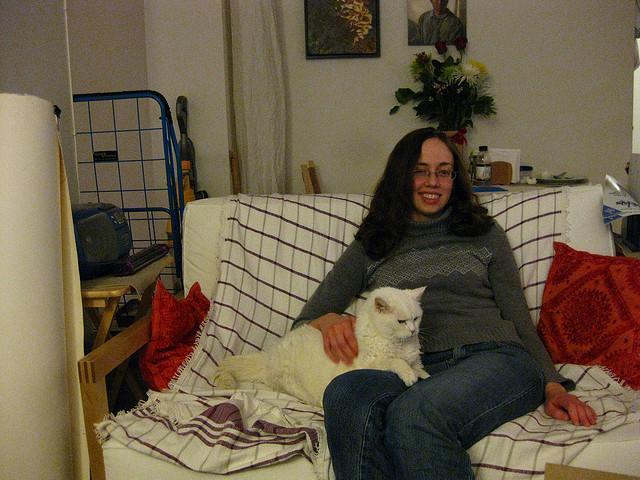How many red pillows are there?
Give a very brief answer. 2. How many laptops in the picture?
Give a very brief answer. 0. 